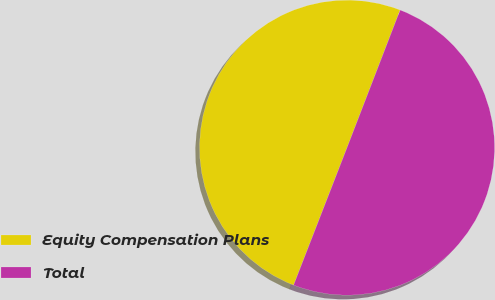Convert chart to OTSL. <chart><loc_0><loc_0><loc_500><loc_500><pie_chart><fcel>Equity Compensation Plans<fcel>Total<nl><fcel>49.96%<fcel>50.04%<nl></chart> 